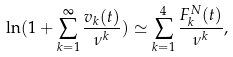Convert formula to latex. <formula><loc_0><loc_0><loc_500><loc_500>\ln ( 1 + \sum _ { k = 1 } ^ { \infty } \frac { v _ { k } ( t ) } { \nu ^ { k } } ) \simeq \sum _ { k = 1 } ^ { 4 } \frac { F _ { k } ^ { N } ( t ) } { \nu ^ { k } } ,</formula> 